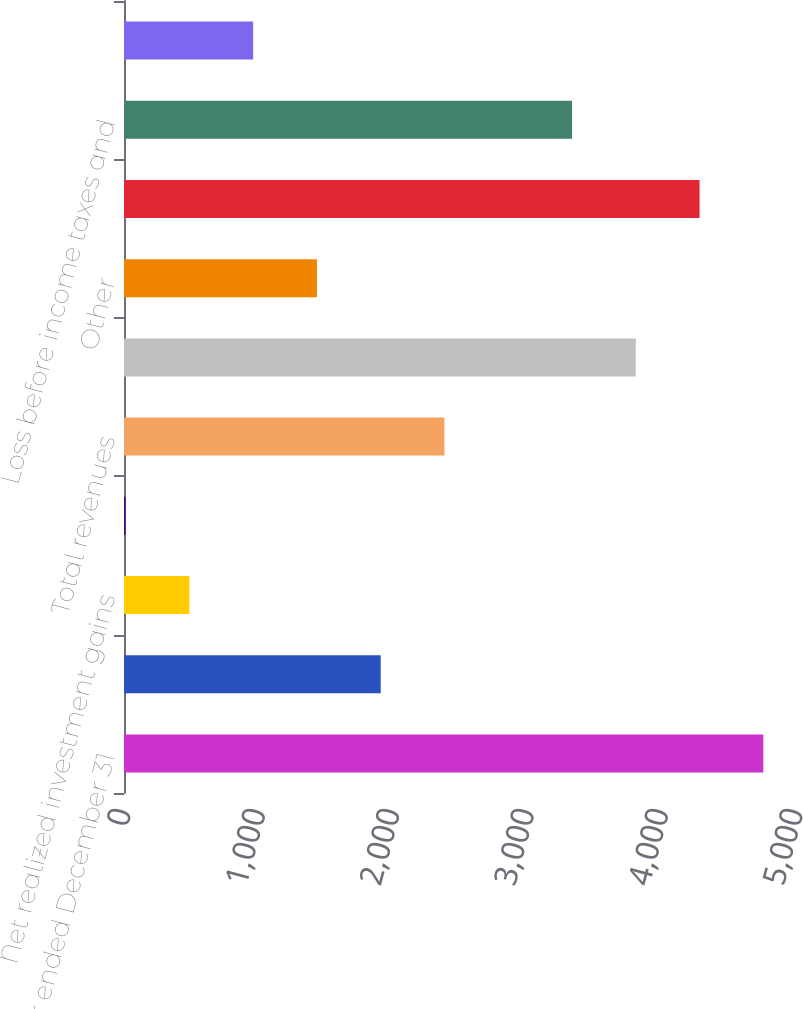Convert chart to OTSL. <chart><loc_0><loc_0><loc_500><loc_500><bar_chart><fcel>For the year ended December 31<fcel>Net investment income<fcel>Net realized investment gains<fcel>Other revenues<fcel>Total revenues<fcel>Interest<fcel>Other<fcel>Total expenses<fcel>Loss before income taxes and<fcel>Income tax expense (benefit)<nl><fcel>4757<fcel>1910<fcel>486.5<fcel>12<fcel>2384.5<fcel>3808<fcel>1435.5<fcel>4282.5<fcel>3333.5<fcel>961<nl></chart> 